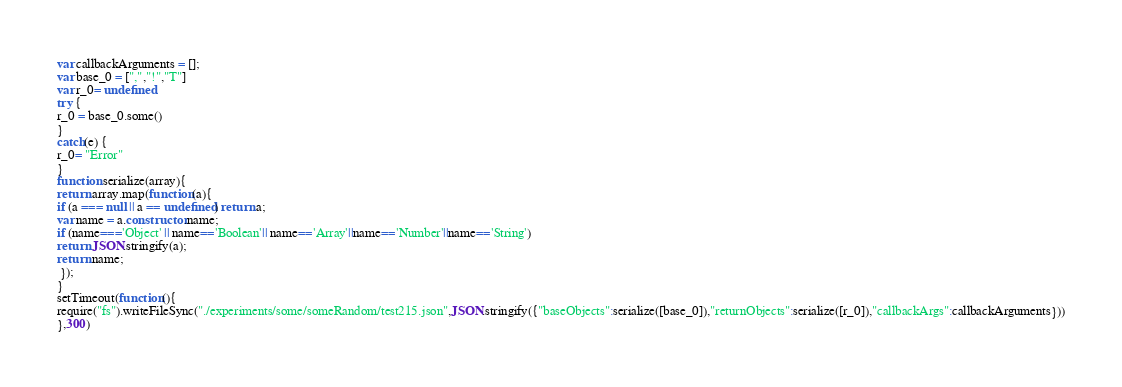Convert code to text. <code><loc_0><loc_0><loc_500><loc_500><_JavaScript_>





var callbackArguments = [];
var base_0 = [",","!","T"]
var r_0= undefined
try {
r_0 = base_0.some()
}
catch(e) {
r_0= "Error"
}
function serialize(array){
return array.map(function(a){
if (a === null || a == undefined) return a;
var name = a.constructor.name;
if (name==='Object' || name=='Boolean'|| name=='Array'||name=='Number'||name=='String')
return JSON.stringify(a);
return name;
 });
}
setTimeout(function(){
require("fs").writeFileSync("./experiments/some/someRandom/test215.json",JSON.stringify({"baseObjects":serialize([base_0]),"returnObjects":serialize([r_0]),"callbackArgs":callbackArguments}))
},300)</code> 